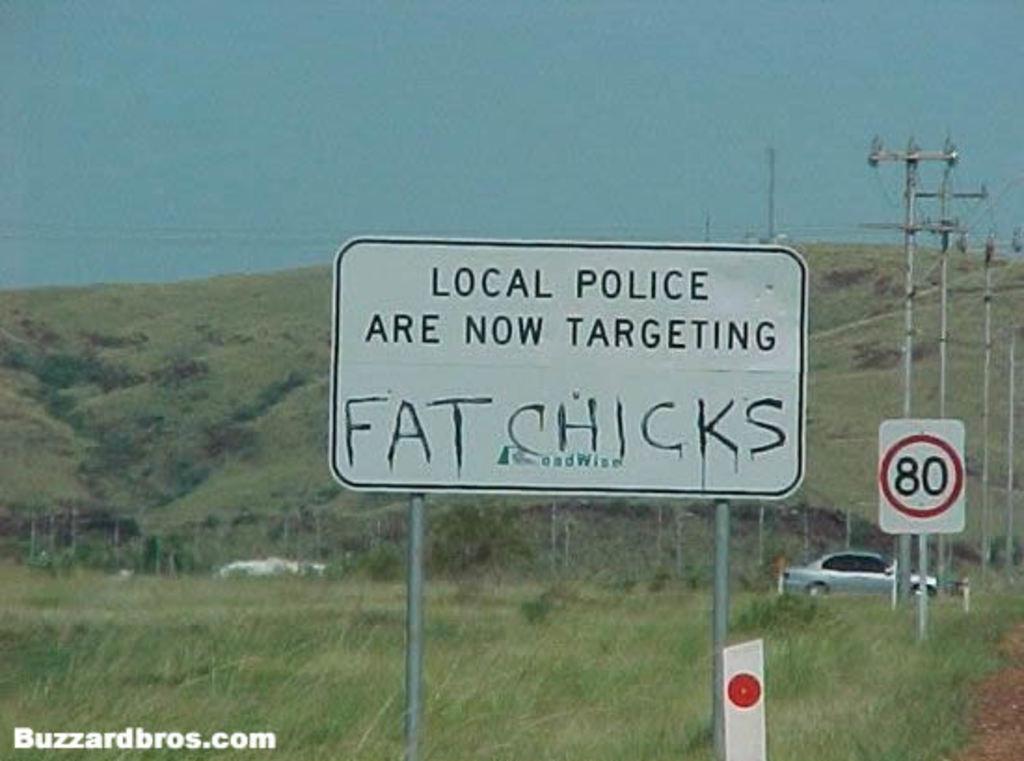Describe this image in one or two sentences. In this image in front there are boards. There are current polls. At the bottom of the image there is grass on the surface. There are cars. In the background of the image there are trees and sky. There is some text on the left side of the image. 